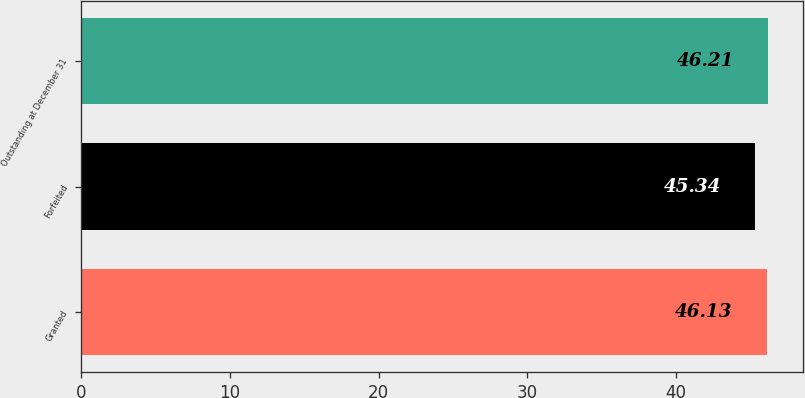Convert chart to OTSL. <chart><loc_0><loc_0><loc_500><loc_500><bar_chart><fcel>Granted<fcel>Forfeited<fcel>Outstanding at December 31<nl><fcel>46.13<fcel>45.34<fcel>46.21<nl></chart> 